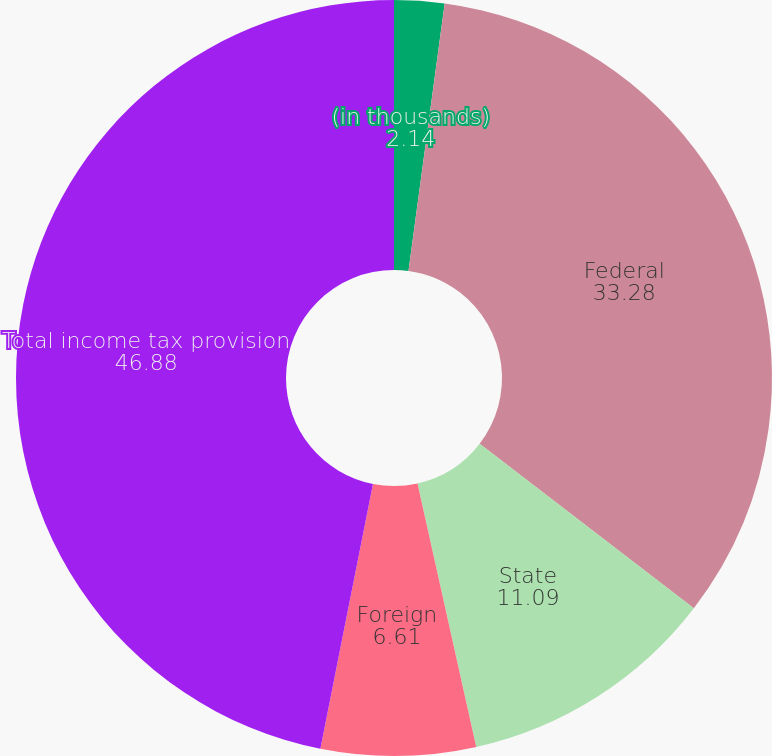<chart> <loc_0><loc_0><loc_500><loc_500><pie_chart><fcel>(in thousands)<fcel>Federal<fcel>State<fcel>Foreign<fcel>Total income tax provision<nl><fcel>2.14%<fcel>33.28%<fcel>11.09%<fcel>6.61%<fcel>46.88%<nl></chart> 